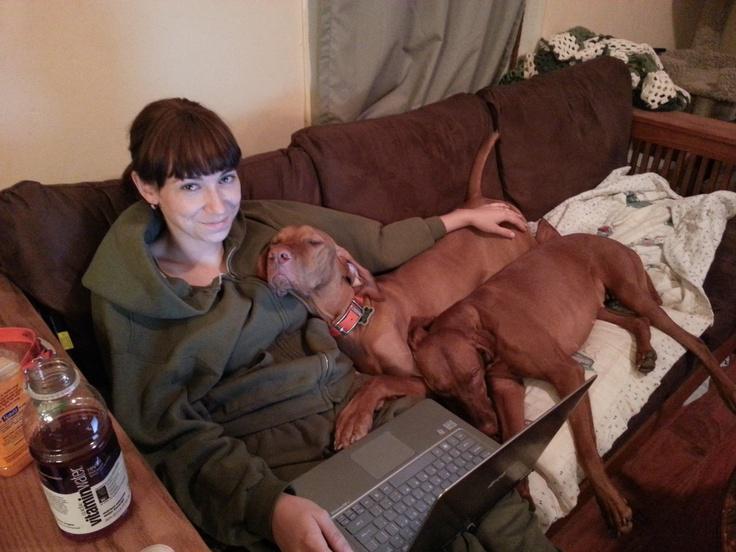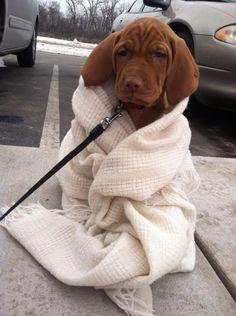The first image is the image on the left, the second image is the image on the right. Evaluate the accuracy of this statement regarding the images: "The right image shows a red-orange dog reclining in a bed with the side of its head on a pillow.". Is it true? Answer yes or no. No. The first image is the image on the left, the second image is the image on the right. Evaluate the accuracy of this statement regarding the images: "There are only two dogs in total.". Is it true? Answer yes or no. No. 